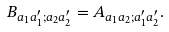Convert formula to latex. <formula><loc_0><loc_0><loc_500><loc_500>B _ { a _ { 1 } a _ { 1 } ^ { \prime } ; a _ { 2 } a _ { 2 } ^ { \prime } } = A _ { a _ { 1 } a _ { 2 } ; a _ { 1 } ^ { \prime } a _ { 2 } ^ { \prime } } .</formula> 